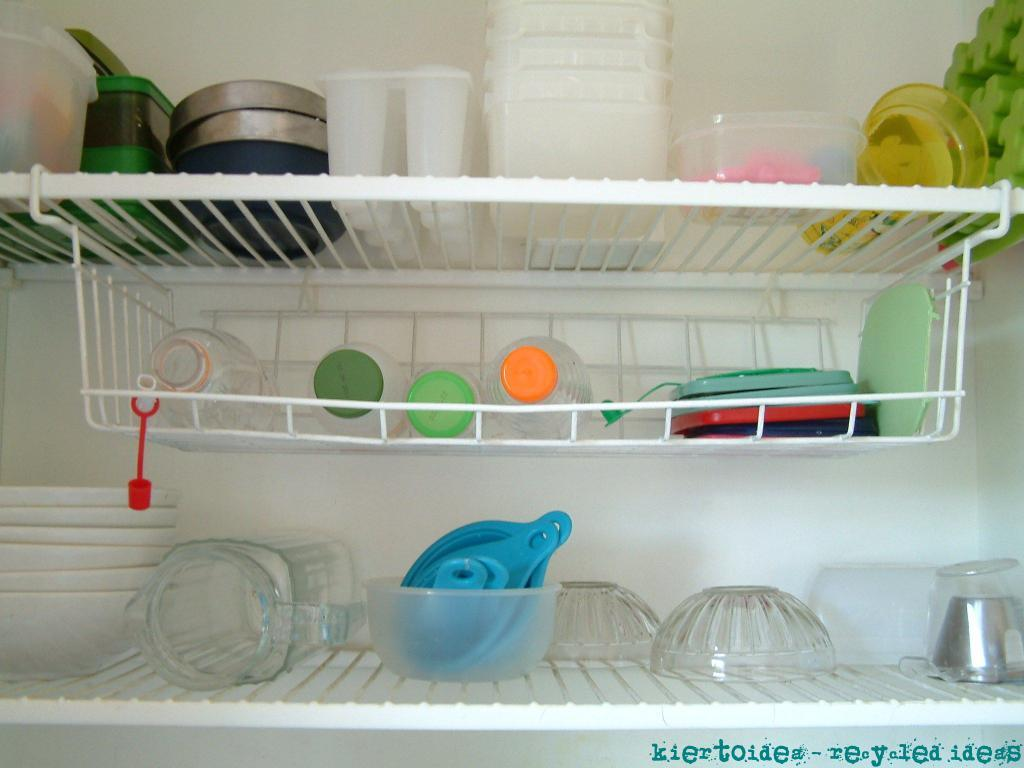What objects are in the center of the image? There are white trays in the center of the image. What items can be seen on the trays? There are bottles, cups, jars, and other utensils on the trays. Can you describe the contents of the trays in more detail? The trays contain bottles, cups, jars, and other utensils, which may include spoons, forks, or knives. What type of caption is written on the bottles in the image? There is no caption written on the bottles in the image; they are simply bottles on the trays. Can you tell me how many pencils are on the trays? There are no pencils present on the trays in the image. 